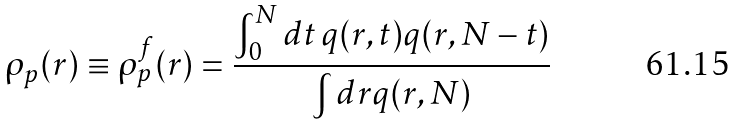<formula> <loc_0><loc_0><loc_500><loc_500>\rho _ { p } ( r ) \equiv \rho _ { p } ^ { f } ( r ) = \frac { \int _ { 0 } ^ { N } d t \, q ( r , t ) q ( r , N - t ) } { \int d r q ( r , N ) }</formula> 